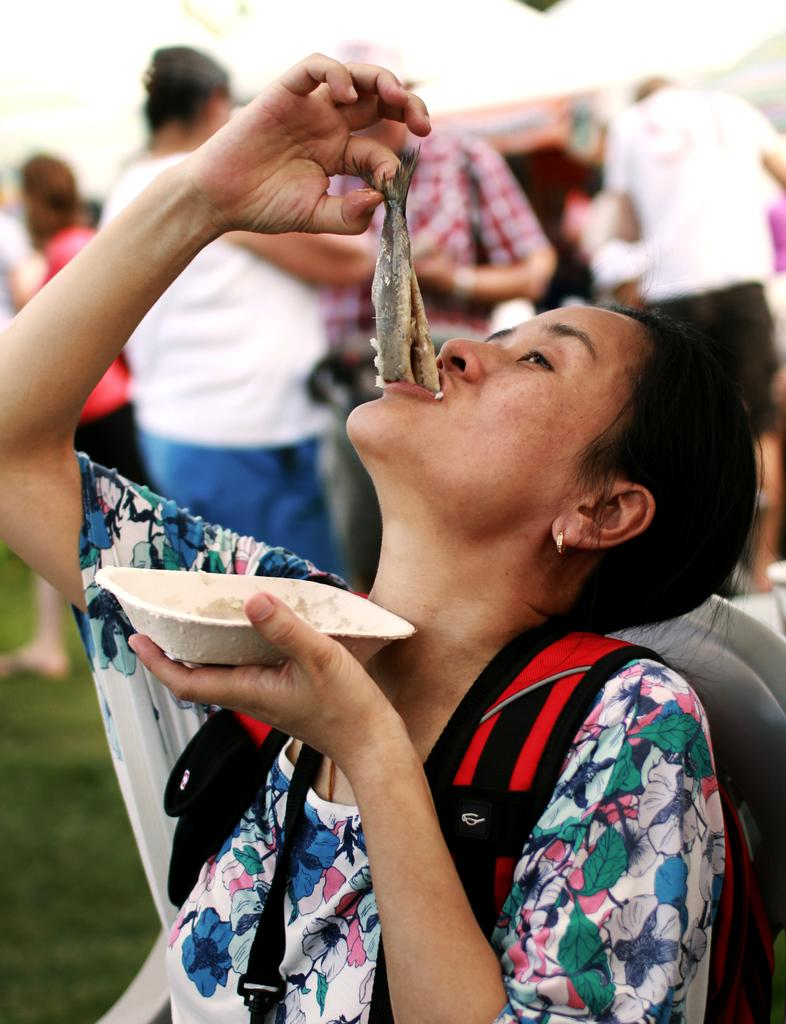Who is the main subject in the image? There is a lady in the image. What is the lady wearing on her back? The lady is wearing a backpack. What is the lady doing in the image? The lady is eating a food item. Are there any other people visible in the image? Yes, there are other people visible in the image. What type of roof can be seen on the lady's head in the image? There is no roof visible on the lady's head in the image. How many eggs are visible in the lady's hand in the image? There are no eggs present in the image. 